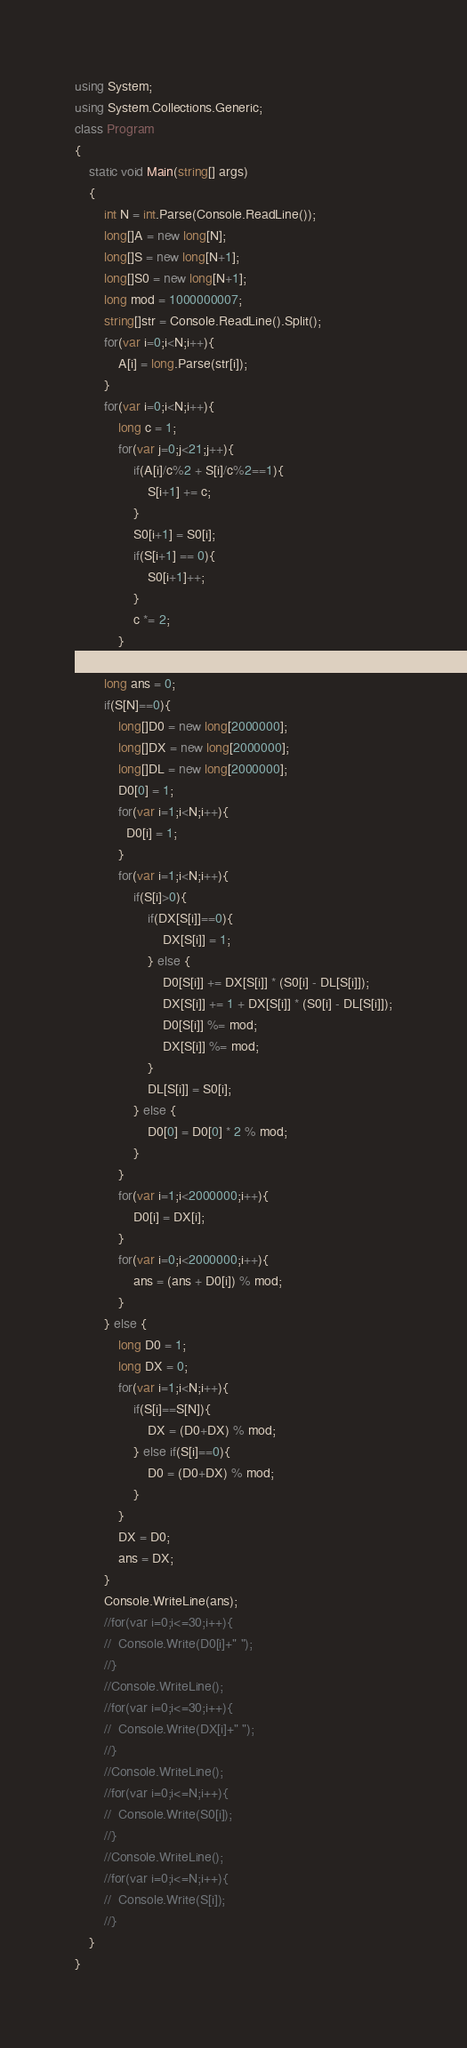<code> <loc_0><loc_0><loc_500><loc_500><_C#_>using System;
using System.Collections.Generic;
class Program
{
	static void Main(string[] args)
	{
		int N = int.Parse(Console.ReadLine());
		long[]A = new long[N];
		long[]S = new long[N+1];
      	long[]S0 = new long[N+1];
      	long mod = 1000000007;
		string[]str = Console.ReadLine().Split();
		for(var i=0;i<N;i++){
			A[i] = long.Parse(str[i]);
		}
		for(var i=0;i<N;i++){
			long c = 1;
			for(var j=0;j<21;j++){
				if(A[i]/c%2 + S[i]/c%2==1){
					S[i+1] += c;
                }
                S0[i+1] = S0[i];
                if(S[i+1] == 0){
                	S0[i+1]++;
                }
				c *= 2;
			}
		}
		long ans = 0;
		if(S[N]==0){
			long[]D0 = new long[2000000];
			long[]DX = new long[2000000];
			long[]DL = new long[2000000];
			D0[0] = 1;
          	for(var i=1;i<N;i++){
              D0[i] = 1;
            }
			for(var i=1;i<N;i++){
				if(S[i]>0){
					if(DX[S[i]]==0){
						DX[S[i]] = 1;
					} else {
						D0[S[i]] += DX[S[i]] * (S0[i] - DL[S[i]]);
						DX[S[i]] += 1 + DX[S[i]] * (S0[i] - DL[S[i]]);
						D0[S[i]] %= mod;
						DX[S[i]] %= mod;
					}
					DL[S[i]] = S0[i];
				} else {
					D0[0] = D0[0] * 2 % mod;
				}
			}
			for(var i=1;i<2000000;i++){
              	D0[i] = DX[i];
            }
			for(var i=0;i<2000000;i++){
				ans = (ans + D0[i]) % mod;
			}
		} else {
			long D0 = 1;
			long DX = 0;
			for(var i=1;i<N;i++){
				if(S[i]==S[N]){
					DX = (D0+DX) % mod;
				} else if(S[i]==0){
					D0 = (D0+DX) % mod;
				}
			}
          	DX = D0;
			ans = DX;
		}
      	Console.WriteLine(ans);
        //for(var i=0;i<=30;i++){
        //  Console.Write(D0[i]+" ");
        //}
      	//Console.WriteLine();
        //for(var i=0;i<=30;i++){
        //  Console.Write(DX[i]+" ");
        //}
      	//Console.WriteLine();
      	//for(var i=0;i<=N;i++){
        //  Console.Write(S0[i]);
        //}
      	//Console.WriteLine();
      	//for(var i=0;i<=N;i++){
        //  Console.Write(S[i]);
        //}
    }
}</code> 